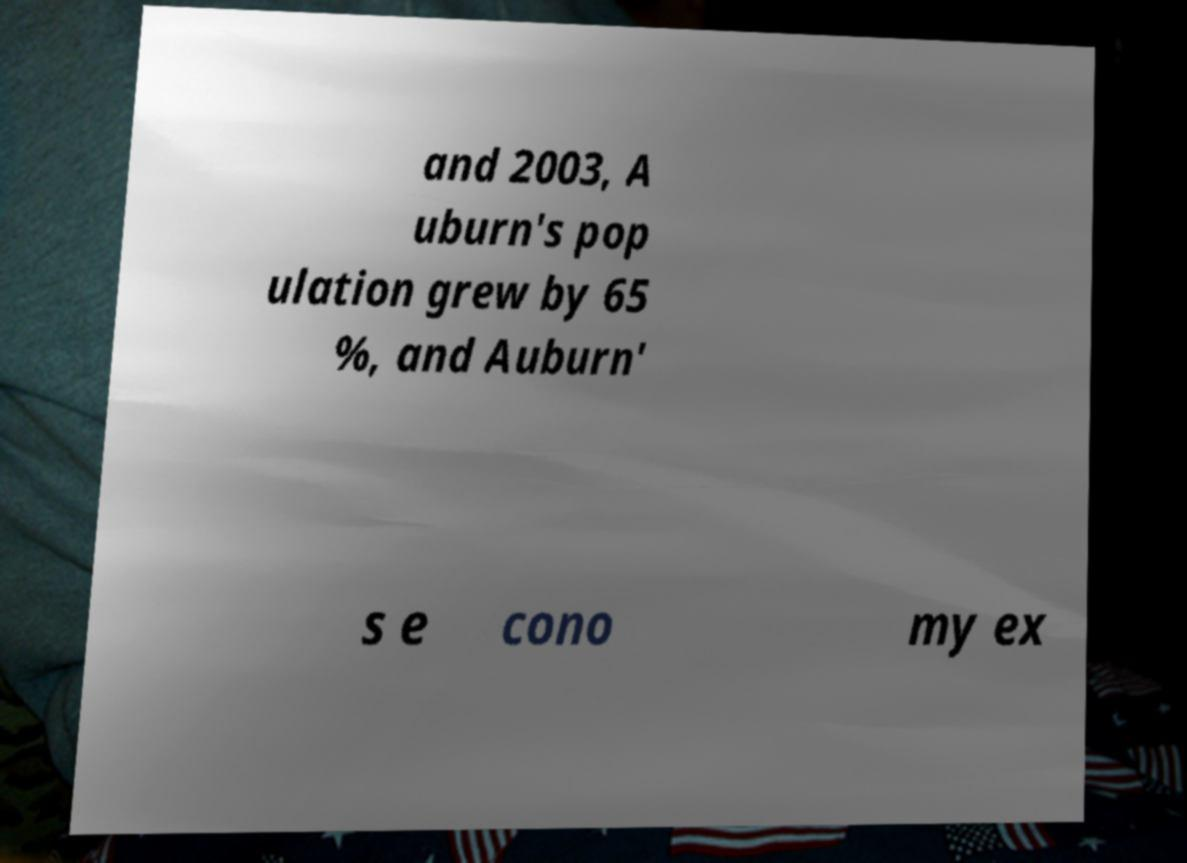Could you extract and type out the text from this image? and 2003, A uburn's pop ulation grew by 65 %, and Auburn' s e cono my ex 